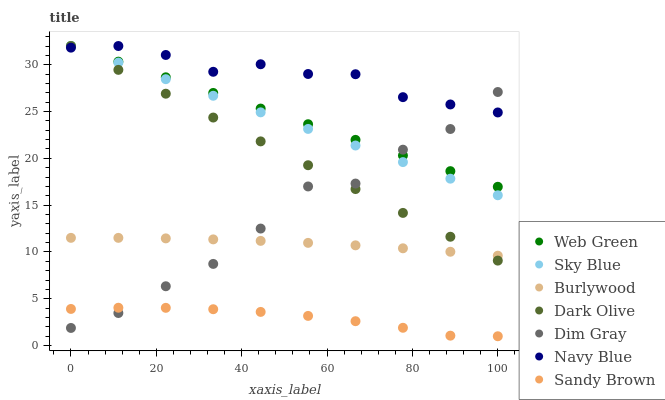Does Sandy Brown have the minimum area under the curve?
Answer yes or no. Yes. Does Navy Blue have the maximum area under the curve?
Answer yes or no. Yes. Does Burlywood have the minimum area under the curve?
Answer yes or no. No. Does Burlywood have the maximum area under the curve?
Answer yes or no. No. Is Sky Blue the smoothest?
Answer yes or no. Yes. Is Dim Gray the roughest?
Answer yes or no. Yes. Is Burlywood the smoothest?
Answer yes or no. No. Is Burlywood the roughest?
Answer yes or no. No. Does Sandy Brown have the lowest value?
Answer yes or no. Yes. Does Burlywood have the lowest value?
Answer yes or no. No. Does Sky Blue have the highest value?
Answer yes or no. Yes. Does Burlywood have the highest value?
Answer yes or no. No. Is Burlywood less than Navy Blue?
Answer yes or no. Yes. Is Burlywood greater than Sandy Brown?
Answer yes or no. Yes. Does Burlywood intersect Dim Gray?
Answer yes or no. Yes. Is Burlywood less than Dim Gray?
Answer yes or no. No. Is Burlywood greater than Dim Gray?
Answer yes or no. No. Does Burlywood intersect Navy Blue?
Answer yes or no. No. 